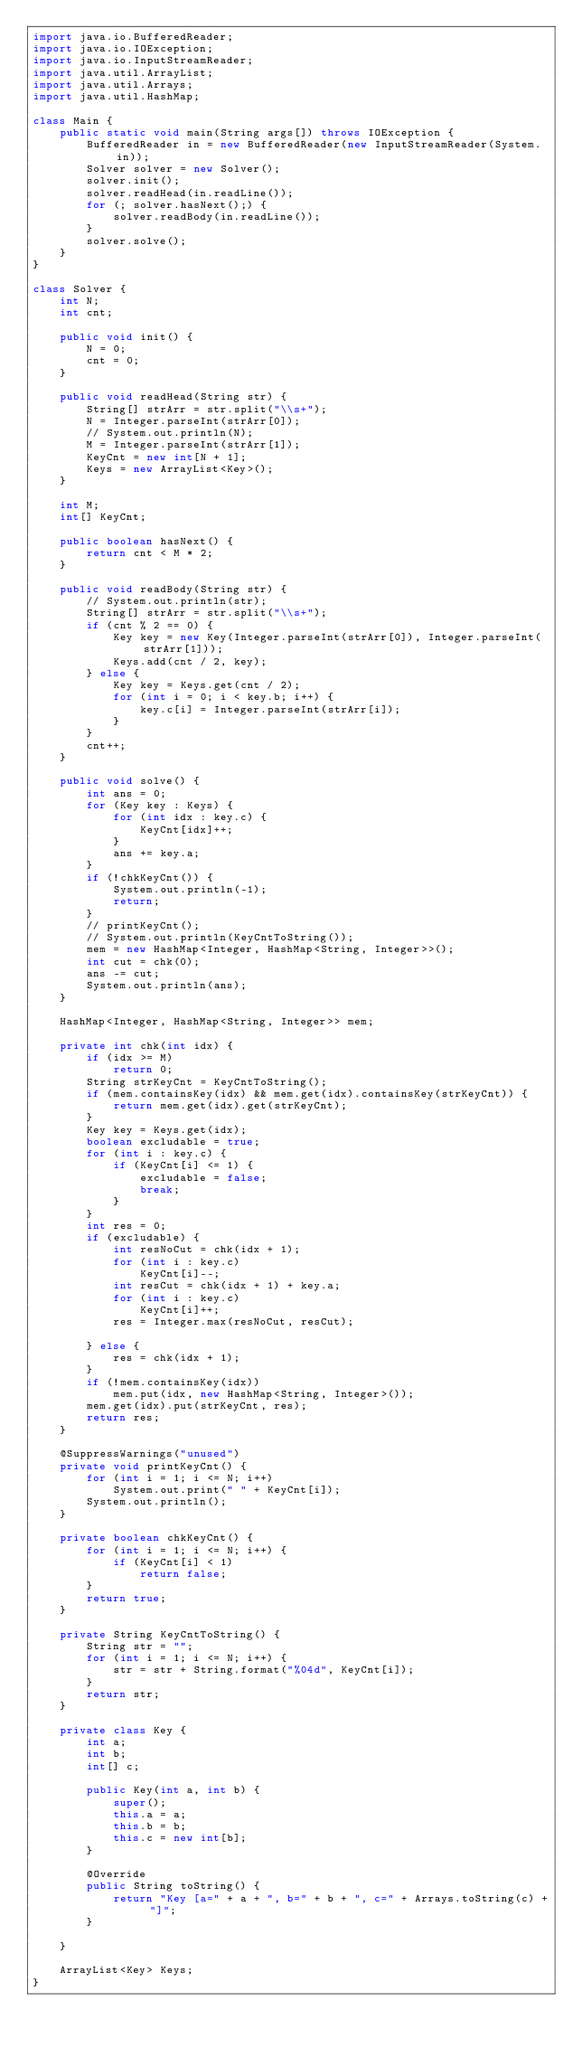Convert code to text. <code><loc_0><loc_0><loc_500><loc_500><_Java_>import java.io.BufferedReader;
import java.io.IOException;
import java.io.InputStreamReader;
import java.util.ArrayList;
import java.util.Arrays;
import java.util.HashMap;

class Main {
	public static void main(String args[]) throws IOException {
		BufferedReader in = new BufferedReader(new InputStreamReader(System.in));
		Solver solver = new Solver();
		solver.init();
		solver.readHead(in.readLine());
		for (; solver.hasNext();) {
			solver.readBody(in.readLine());
		}
		solver.solve();
	}
}

class Solver {
	int N;
	int cnt;

	public void init() {
		N = 0;
		cnt = 0;
	}

	public void readHead(String str) {
		String[] strArr = str.split("\\s+");
		N = Integer.parseInt(strArr[0]);
		// System.out.println(N);
		M = Integer.parseInt(strArr[1]);
		KeyCnt = new int[N + 1];
		Keys = new ArrayList<Key>();
	}

	int M;
	int[] KeyCnt;

	public boolean hasNext() {
		return cnt < M * 2;
	}

	public void readBody(String str) {
		// System.out.println(str);
		String[] strArr = str.split("\\s+");
		if (cnt % 2 == 0) {
			Key key = new Key(Integer.parseInt(strArr[0]), Integer.parseInt(strArr[1]));
			Keys.add(cnt / 2, key);
		} else {
			Key key = Keys.get(cnt / 2);
			for (int i = 0; i < key.b; i++) {
				key.c[i] = Integer.parseInt(strArr[i]);
			}
		}
		cnt++;
	}

	public void solve() {
		int ans = 0;
		for (Key key : Keys) {
			for (int idx : key.c) {
				KeyCnt[idx]++;
			}
			ans += key.a;
		}
		if (!chkKeyCnt()) {
			System.out.println(-1);
			return;
		}
		// printKeyCnt();
		// System.out.println(KeyCntToString());
		mem = new HashMap<Integer, HashMap<String, Integer>>();
		int cut = chk(0);
		ans -= cut;
		System.out.println(ans);
	}

	HashMap<Integer, HashMap<String, Integer>> mem;

	private int chk(int idx) {
		if (idx >= M)
			return 0;
		String strKeyCnt = KeyCntToString();
		if (mem.containsKey(idx) && mem.get(idx).containsKey(strKeyCnt)) {
			return mem.get(idx).get(strKeyCnt);
		}
		Key key = Keys.get(idx);
		boolean excludable = true;
		for (int i : key.c) {
			if (KeyCnt[i] <= 1) {
				excludable = false;
				break;
			}
		}
		int res = 0;
		if (excludable) {
			int resNoCut = chk(idx + 1);
			for (int i : key.c)
				KeyCnt[i]--;
			int resCut = chk(idx + 1) + key.a;
			for (int i : key.c)
				KeyCnt[i]++;
			res = Integer.max(resNoCut, resCut);

		} else {
			res = chk(idx + 1);
		}
		if (!mem.containsKey(idx))
			mem.put(idx, new HashMap<String, Integer>());
		mem.get(idx).put(strKeyCnt, res);
		return res;
	}

	@SuppressWarnings("unused")
	private void printKeyCnt() {
		for (int i = 1; i <= N; i++)
			System.out.print(" " + KeyCnt[i]);
		System.out.println();
	}

	private boolean chkKeyCnt() {
		for (int i = 1; i <= N; i++) {
			if (KeyCnt[i] < 1)
				return false;
		}
		return true;
	}

	private String KeyCntToString() {
		String str = "";
		for (int i = 1; i <= N; i++) {
			str = str + String.format("%04d", KeyCnt[i]);
		}
		return str;
	}

	private class Key {
		int a;
		int b;
		int[] c;

		public Key(int a, int b) {
			super();
			this.a = a;
			this.b = b;
			this.c = new int[b];
		}

		@Override
		public String toString() {
			return "Key [a=" + a + ", b=" + b + ", c=" + Arrays.toString(c) + "]";
		}

	}

	ArrayList<Key> Keys;
}
</code> 